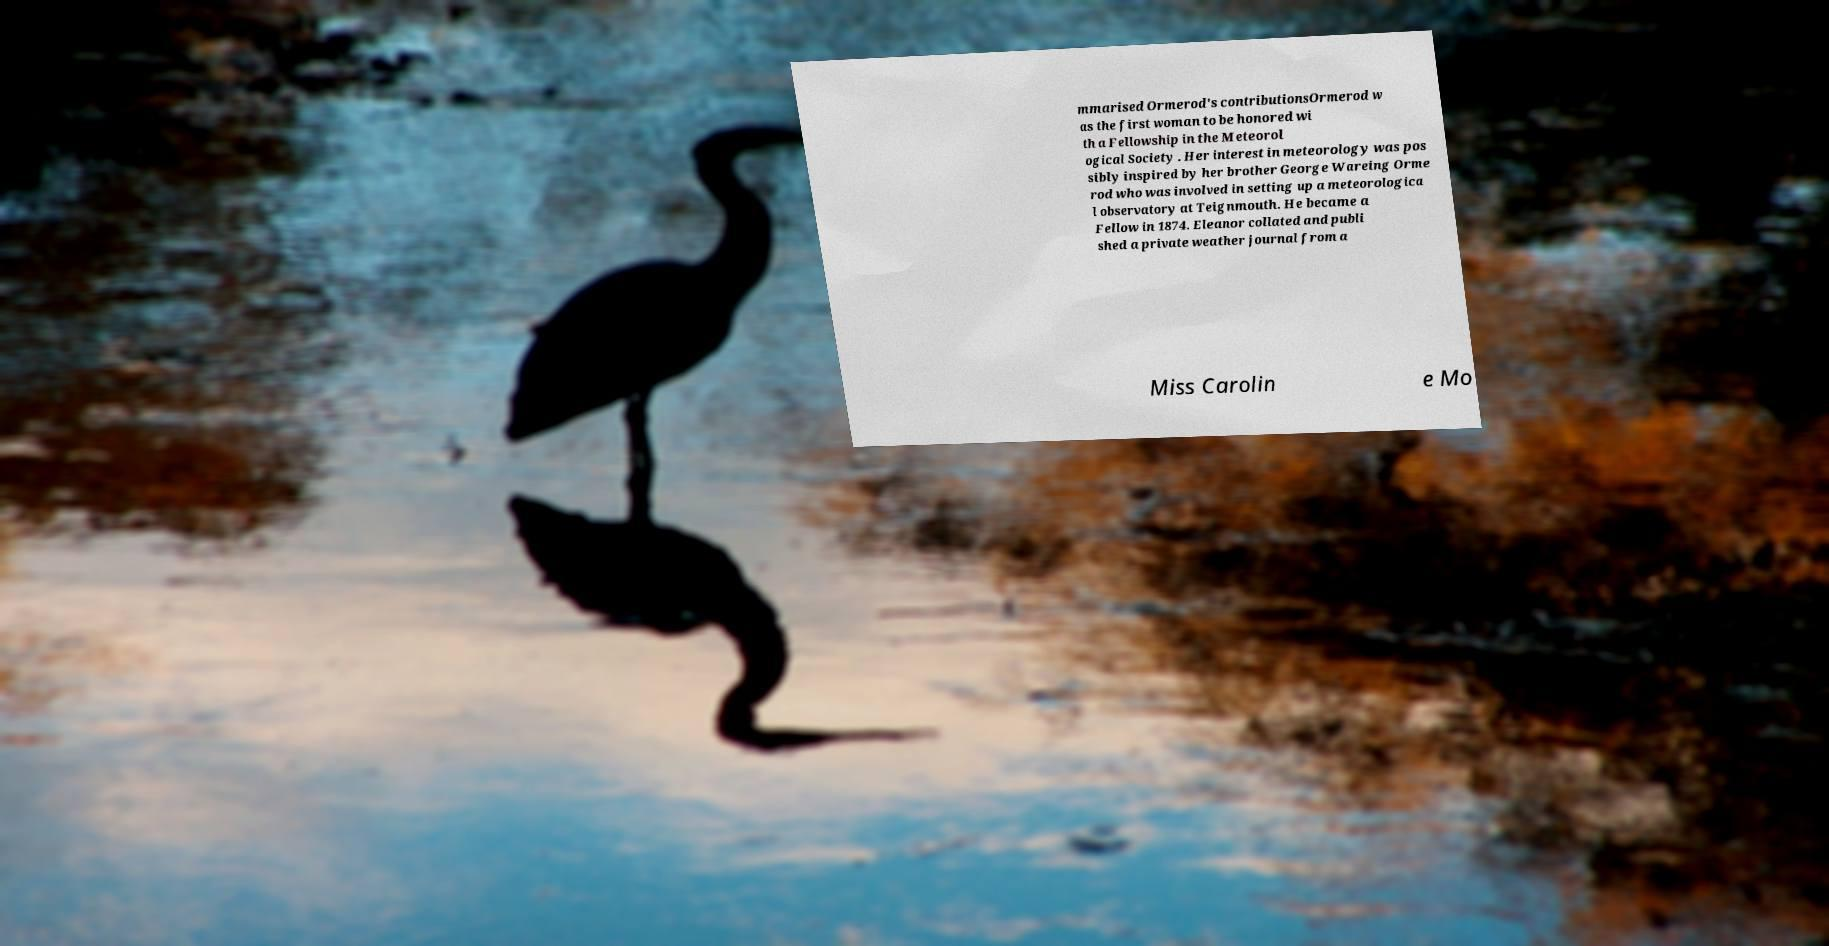For documentation purposes, I need the text within this image transcribed. Could you provide that? mmarised Ormerod's contributionsOrmerod w as the first woman to be honored wi th a Fellowship in the Meteorol ogical Society . Her interest in meteorology was pos sibly inspired by her brother George Wareing Orme rod who was involved in setting up a meteorologica l observatory at Teignmouth. He became a Fellow in 1874. Eleanor collated and publi shed a private weather journal from a Miss Carolin e Mo 